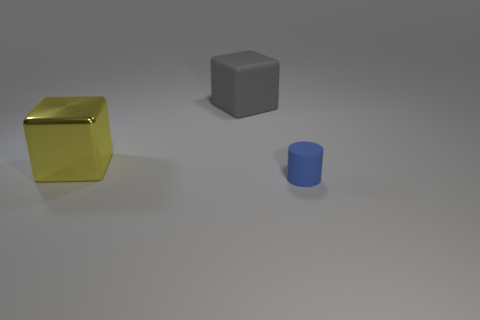Is there anything else that has the same size as the cylinder?
Offer a terse response. No. There is a thing that is behind the big yellow metal thing; what is its shape?
Your answer should be compact. Cube. How many yellow metallic objects are there?
Your response must be concise. 1. Does the gray object have the same material as the blue thing?
Provide a short and direct response. Yes. Is the number of cylinders to the right of the matte cube greater than the number of brown rubber blocks?
Offer a terse response. Yes. What number of things are either tiny blue rubber cylinders or matte objects behind the small blue rubber thing?
Keep it short and to the point. 2. Is the number of metallic things behind the cylinder greater than the number of blue things that are to the left of the big matte cube?
Offer a terse response. Yes. What material is the big cube in front of the rubber thing on the left side of the thing that is in front of the yellow thing made of?
Give a very brief answer. Metal. The gray thing that is made of the same material as the cylinder is what shape?
Your answer should be very brief. Cube. Are there any big cubes that are in front of the matte object left of the small blue matte cylinder?
Your answer should be compact. Yes. 